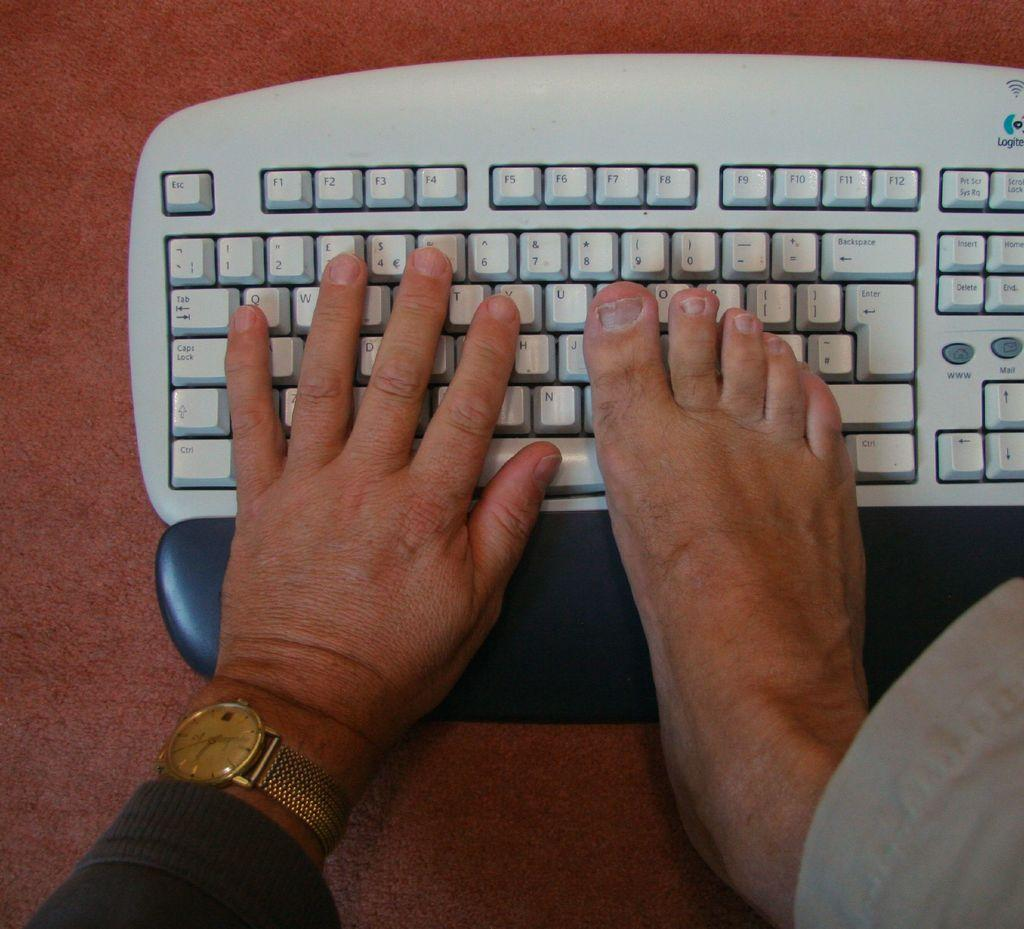<image>
Describe the image concisely. A Logitech keyboard has one hand and one foot on it. 